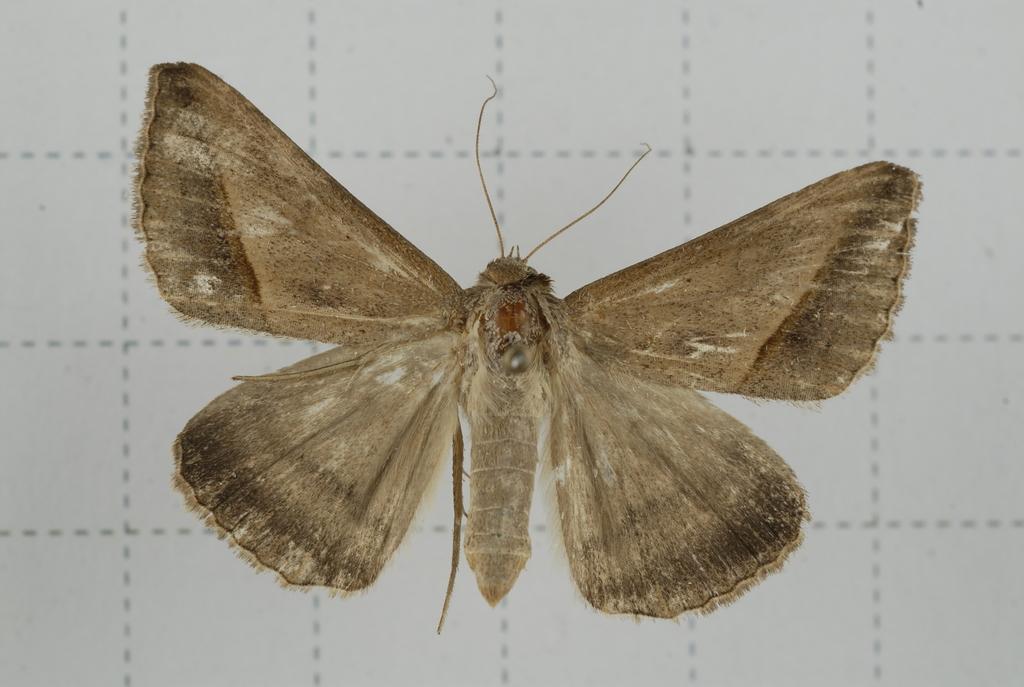Describe this image in one or two sentences. In this image I can see the butterfly which is in brown and black color. It is on the white color surface. 